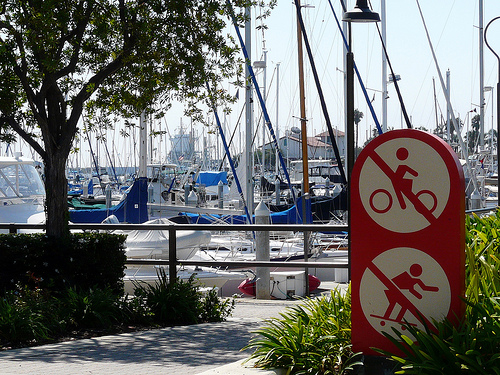<image>
Can you confirm if the sky is behind the pillar? Yes. From this viewpoint, the sky is positioned behind the pillar, with the pillar partially or fully occluding the sky. 